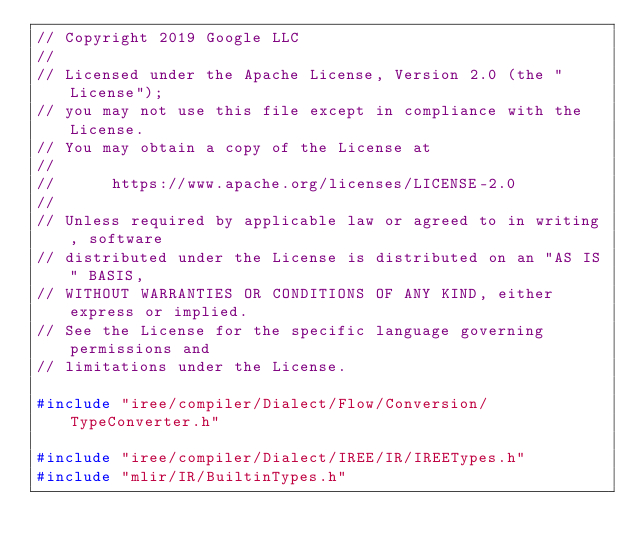Convert code to text. <code><loc_0><loc_0><loc_500><loc_500><_C++_>// Copyright 2019 Google LLC
//
// Licensed under the Apache License, Version 2.0 (the "License");
// you may not use this file except in compliance with the License.
// You may obtain a copy of the License at
//
//      https://www.apache.org/licenses/LICENSE-2.0
//
// Unless required by applicable law or agreed to in writing, software
// distributed under the License is distributed on an "AS IS" BASIS,
// WITHOUT WARRANTIES OR CONDITIONS OF ANY KIND, either express or implied.
// See the License for the specific language governing permissions and
// limitations under the License.

#include "iree/compiler/Dialect/Flow/Conversion/TypeConverter.h"

#include "iree/compiler/Dialect/IREE/IR/IREETypes.h"
#include "mlir/IR/BuiltinTypes.h"
</code> 